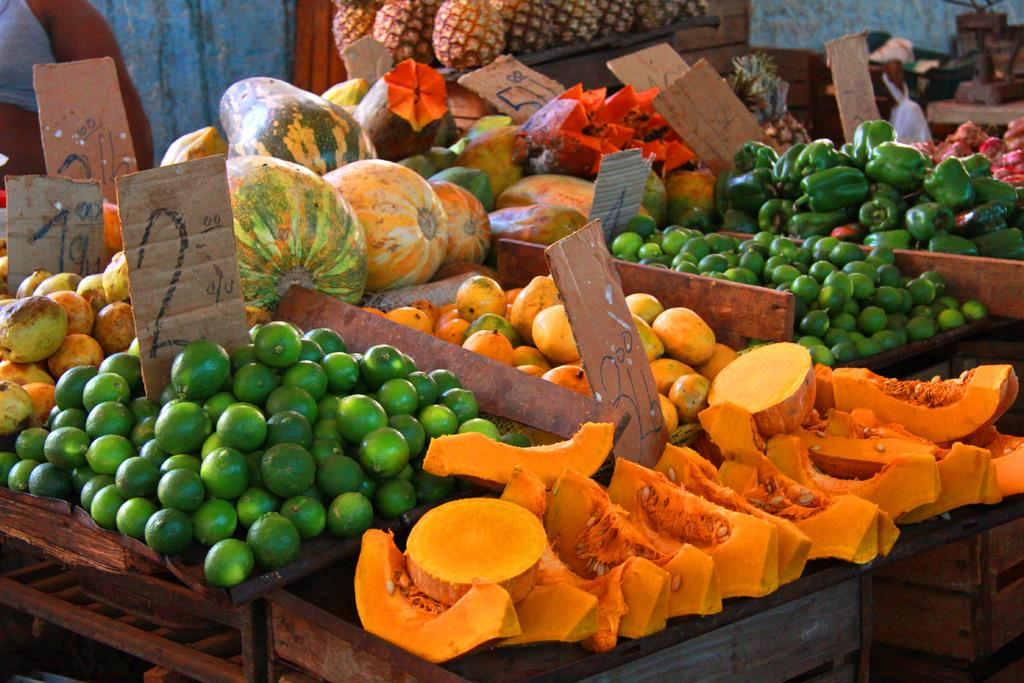What types of food items are present in the image? The image contains fruits and vegetables. Where are the fruits and vegetables placed? The fruits and vegetables are kept on a desk. What can be seen at the bottom of the image? There are wooden boxes at the bottom of the image. What type of fruit is visible in the background of the image? Pineapples are visible in the background of the image. What type of crow can be seen interacting with the vegetables in the image? There is no crow present in the image. 